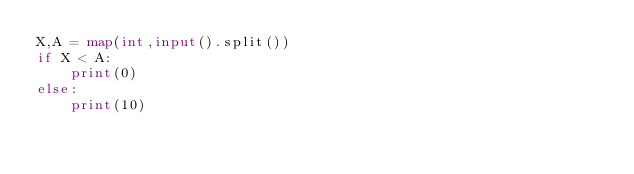<code> <loc_0><loc_0><loc_500><loc_500><_Python_>X,A = map(int,input().split())
if X < A:
    print(0)
else:
    print(10)</code> 